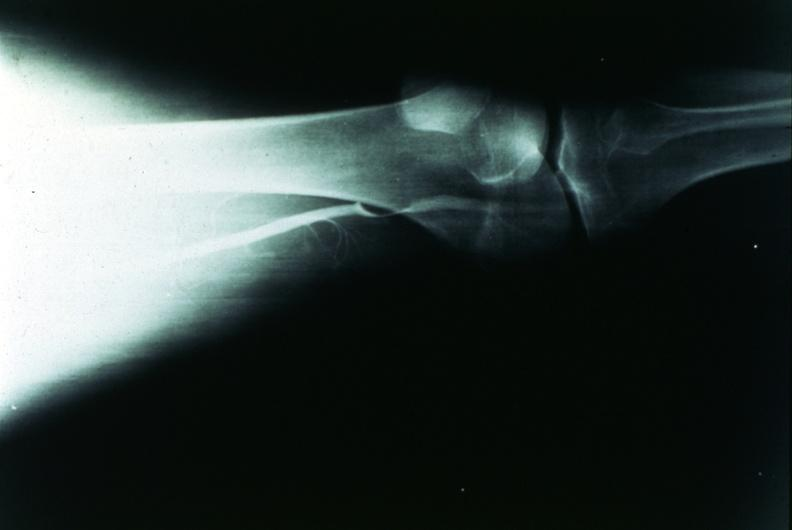what does this image show?
Answer the question using a single word or phrase. Popliteal cyst 